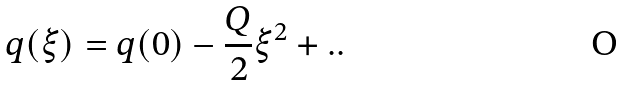<formula> <loc_0><loc_0><loc_500><loc_500>q ( \xi ) = q ( 0 ) - \frac { Q } { 2 } \xi ^ { 2 } + . .</formula> 